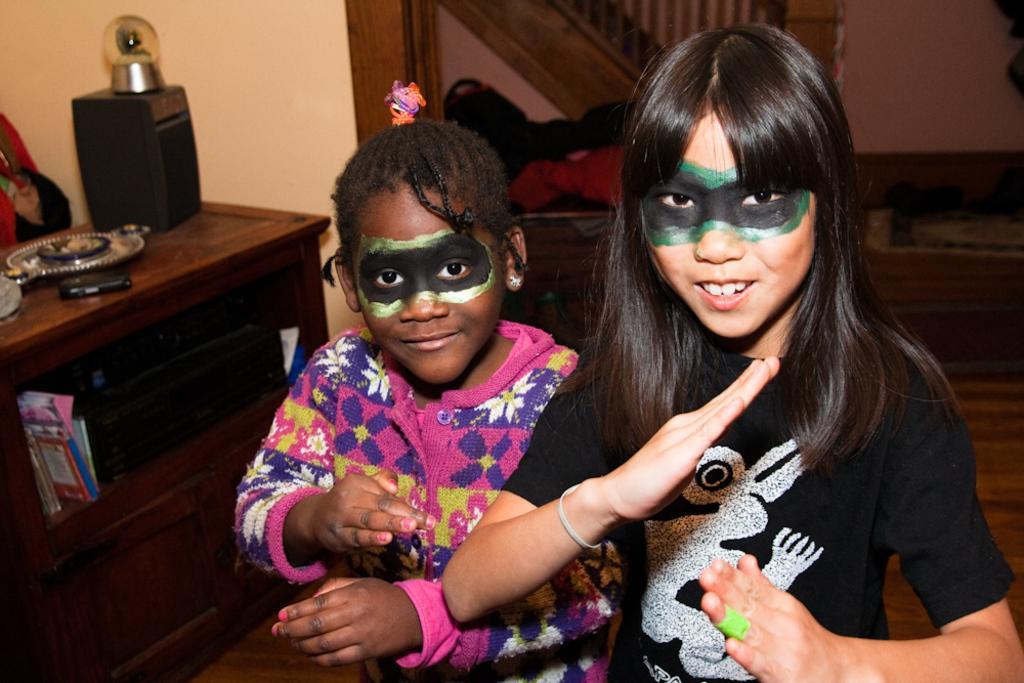Describe this image in one or two sentences. In this image we can see two people, behind them there is a table with some objects on it. In the background we can see a handrail and the wall. 